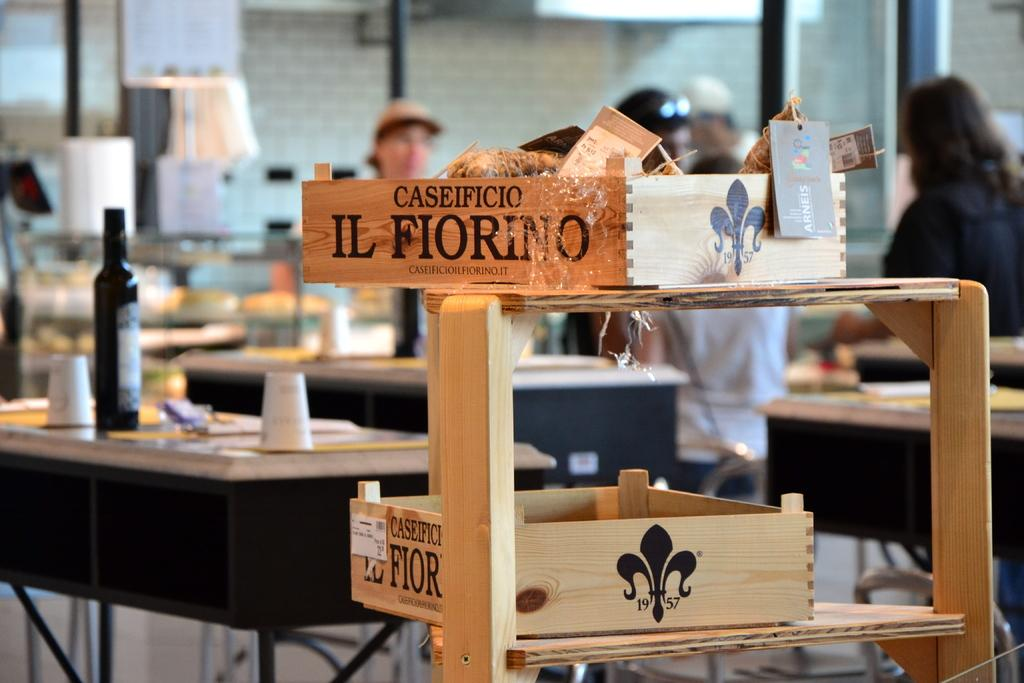What object is located in the foreground of the image? There is a wooden block in the foreground of the image. What can be seen in the background of the image? There is a group of persons in the background of the image. Where is the bottle located in the image? The bottle is on the left side of the image. What type of help can be provided by the wooden block in the image? The wooden block is an inanimate object and cannot provide help. What suggestions can be made by the bottle in the image? The bottle is an inanimate object and cannot make suggestions. 